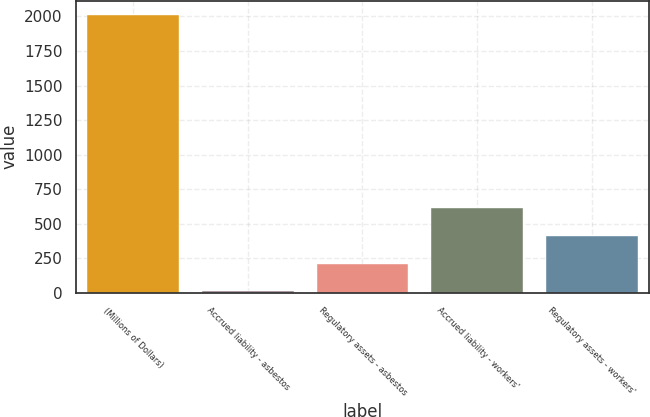<chart> <loc_0><loc_0><loc_500><loc_500><bar_chart><fcel>(Millions of Dollars)<fcel>Accrued liability - asbestos<fcel>Regulatory assets - asbestos<fcel>Accrued liability - workers'<fcel>Regulatory assets - workers'<nl><fcel>2012<fcel>10<fcel>210.2<fcel>610.6<fcel>410.4<nl></chart> 